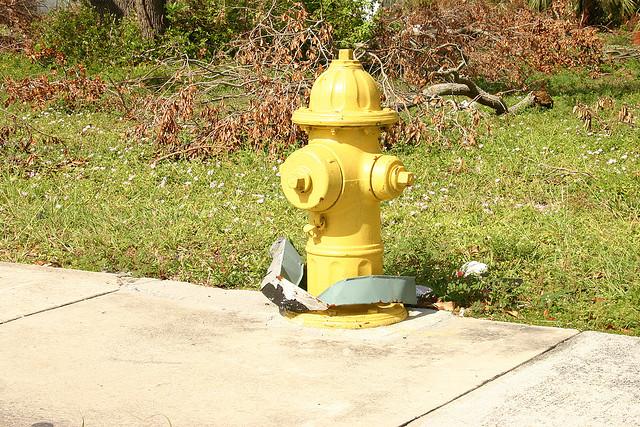Is this hydrant old?
Short answer required. Yes. What is at the base of the fire hydrant?
Give a very brief answer. Trash. Why are the leaves on the branch brown?
Write a very short answer. They are dead. Do fire extinguishers normally look like that?
Write a very short answer. Yes. Is the hydrant centered in the sidewalk slab?
Concise answer only. No. 